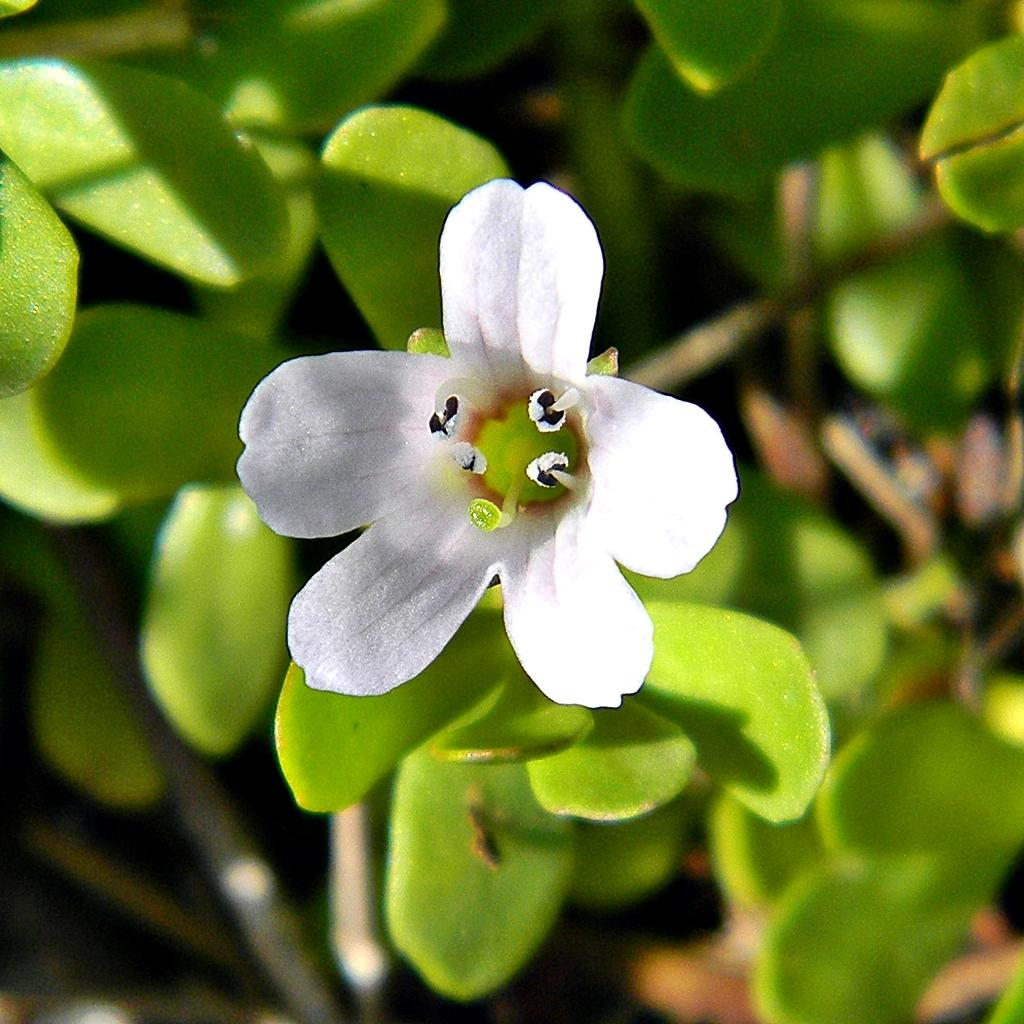What is the main subject in the center of the image? There is a flower in the center of the image. What color is the flower? The flower is white. What else can be seen at the bottom of the image? There are plants at the bottom of the image. What type of collar can be seen on the doll in the image? There is no doll or collar present in the image; it features a white flower and plants. 